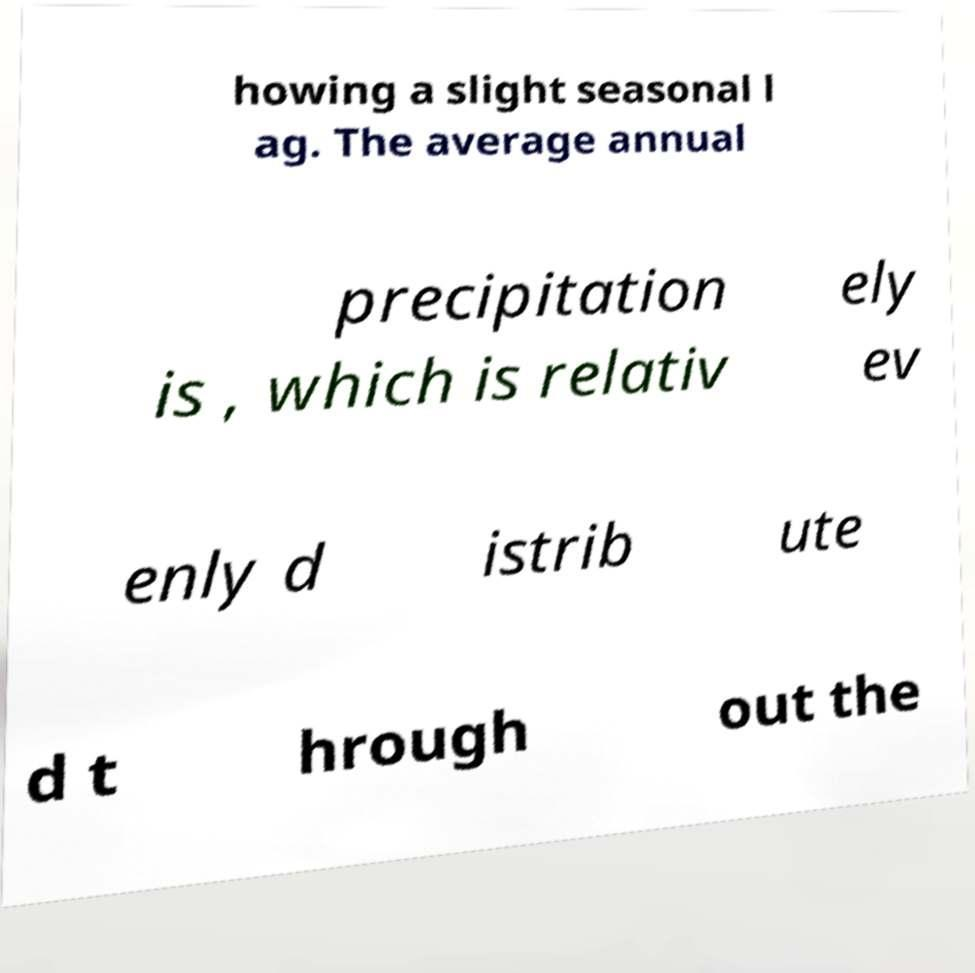For documentation purposes, I need the text within this image transcribed. Could you provide that? howing a slight seasonal l ag. The average annual precipitation is , which is relativ ely ev enly d istrib ute d t hrough out the 